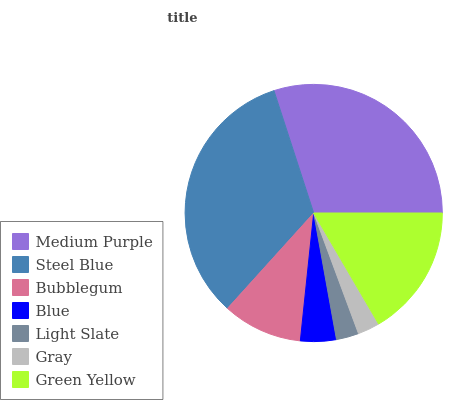Is Gray the minimum?
Answer yes or no. Yes. Is Steel Blue the maximum?
Answer yes or no. Yes. Is Bubblegum the minimum?
Answer yes or no. No. Is Bubblegum the maximum?
Answer yes or no. No. Is Steel Blue greater than Bubblegum?
Answer yes or no. Yes. Is Bubblegum less than Steel Blue?
Answer yes or no. Yes. Is Bubblegum greater than Steel Blue?
Answer yes or no. No. Is Steel Blue less than Bubblegum?
Answer yes or no. No. Is Bubblegum the high median?
Answer yes or no. Yes. Is Bubblegum the low median?
Answer yes or no. Yes. Is Medium Purple the high median?
Answer yes or no. No. Is Blue the low median?
Answer yes or no. No. 